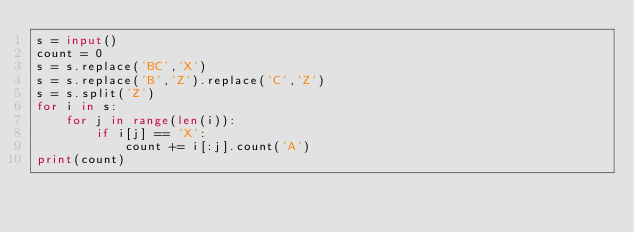<code> <loc_0><loc_0><loc_500><loc_500><_Python_>s = input()
count = 0
s = s.replace('BC','X')
s = s.replace('B','Z').replace('C','Z')
s = s.split('Z')
for i in s:
    for j in range(len(i)):
        if i[j] == 'X':
            count += i[:j].count('A')
print(count)</code> 